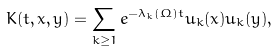<formula> <loc_0><loc_0><loc_500><loc_500>K ( t , { x } , { y } ) = \sum _ { k \geq 1 } e ^ { - \lambda _ { k } ( \Omega ) t } u _ { k } ( { x } ) u _ { k } ( { y } ) ,</formula> 